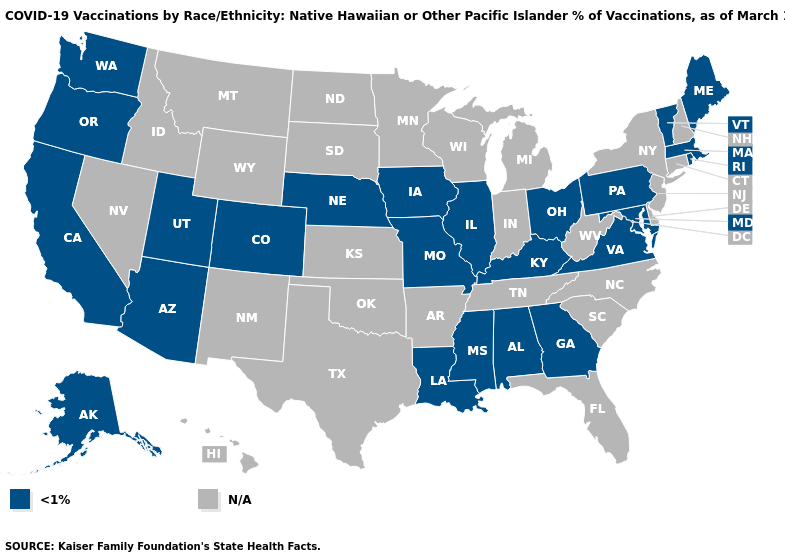Does the first symbol in the legend represent the smallest category?
Quick response, please. Yes. What is the value of California?
Answer briefly. <1%. Name the states that have a value in the range N/A?
Answer briefly. Arkansas, Connecticut, Delaware, Florida, Hawaii, Idaho, Indiana, Kansas, Michigan, Minnesota, Montana, Nevada, New Hampshire, New Jersey, New Mexico, New York, North Carolina, North Dakota, Oklahoma, South Carolina, South Dakota, Tennessee, Texas, West Virginia, Wisconsin, Wyoming. What is the value of Virginia?
Give a very brief answer. <1%. What is the lowest value in states that border Georgia?
Answer briefly. <1%. Name the states that have a value in the range N/A?
Answer briefly. Arkansas, Connecticut, Delaware, Florida, Hawaii, Idaho, Indiana, Kansas, Michigan, Minnesota, Montana, Nevada, New Hampshire, New Jersey, New Mexico, New York, North Carolina, North Dakota, Oklahoma, South Carolina, South Dakota, Tennessee, Texas, West Virginia, Wisconsin, Wyoming. Which states hav the highest value in the South?
Quick response, please. Alabama, Georgia, Kentucky, Louisiana, Maryland, Mississippi, Virginia. What is the lowest value in the USA?
Short answer required. <1%. What is the highest value in states that border New Mexico?
Write a very short answer. <1%. Name the states that have a value in the range <1%?
Give a very brief answer. Alabama, Alaska, Arizona, California, Colorado, Georgia, Illinois, Iowa, Kentucky, Louisiana, Maine, Maryland, Massachusetts, Mississippi, Missouri, Nebraska, Ohio, Oregon, Pennsylvania, Rhode Island, Utah, Vermont, Virginia, Washington. 